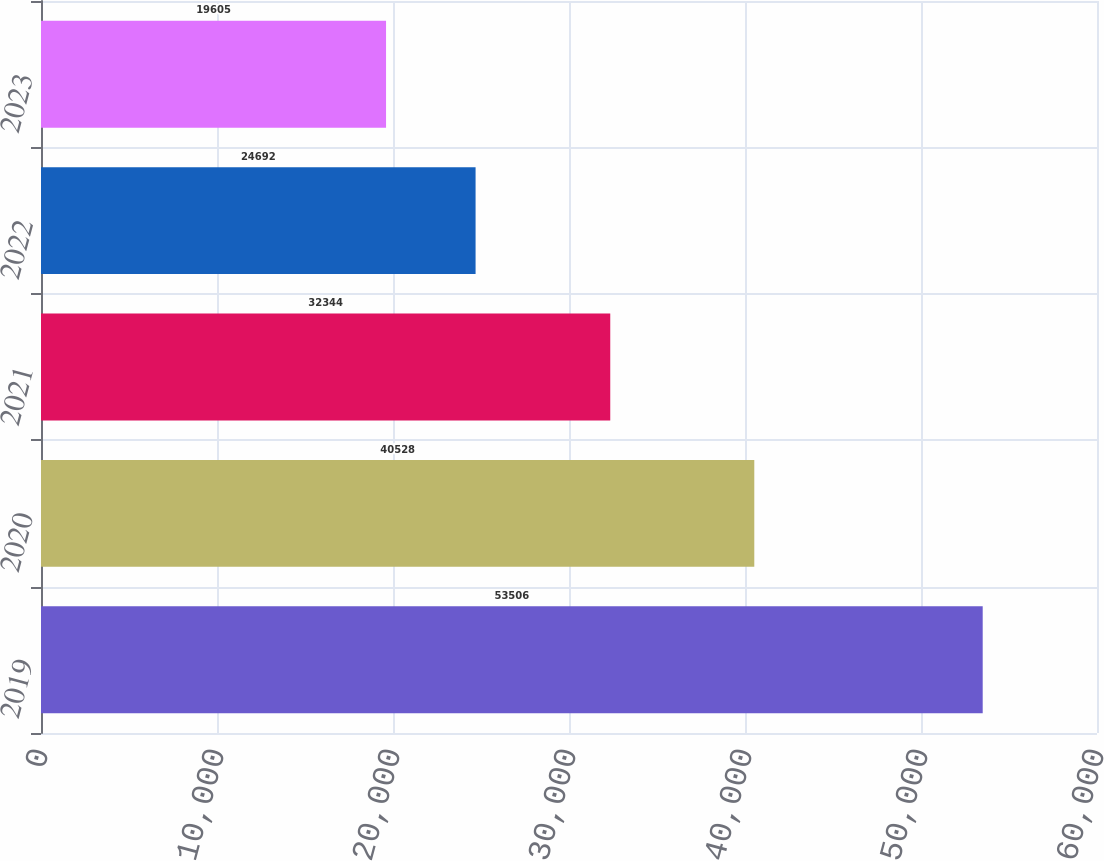<chart> <loc_0><loc_0><loc_500><loc_500><bar_chart><fcel>2019<fcel>2020<fcel>2021<fcel>2022<fcel>2023<nl><fcel>53506<fcel>40528<fcel>32344<fcel>24692<fcel>19605<nl></chart> 